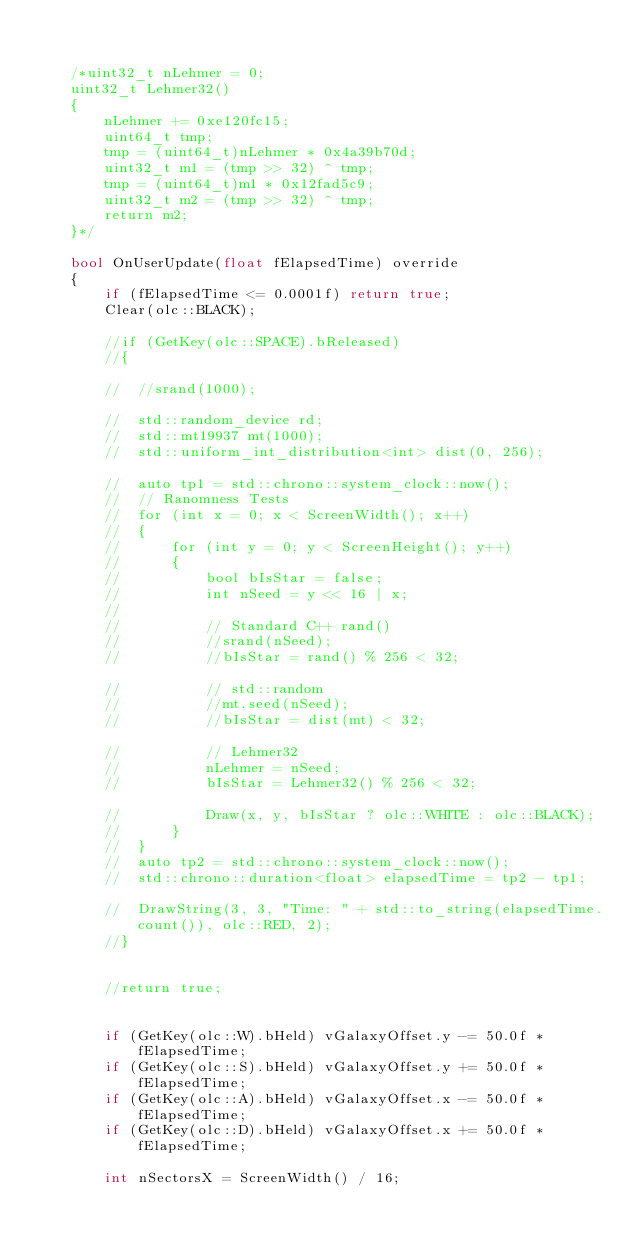<code> <loc_0><loc_0><loc_500><loc_500><_C++_>

	/*uint32_t nLehmer = 0;
	uint32_t Lehmer32()
	{
		nLehmer += 0xe120fc15;
		uint64_t tmp;
		tmp = (uint64_t)nLehmer * 0x4a39b70d;
		uint32_t m1 = (tmp >> 32) ^ tmp;
		tmp = (uint64_t)m1 * 0x12fad5c9;
		uint32_t m2 = (tmp >> 32) ^ tmp;
		return m2;
	}*/

	bool OnUserUpdate(float fElapsedTime) override
	{
		if (fElapsedTime <= 0.0001f) return true;
		Clear(olc::BLACK);

		//if (GetKey(olc::SPACE).bReleased)
		//{

		//	//srand(1000);

		//	std::random_device rd;
		//	std::mt19937 mt(1000);
		//	std::uniform_int_distribution<int> dist(0, 256);

		//	auto tp1 = std::chrono::system_clock::now();
		//	// Ranomness Tests
		//	for (int x = 0; x < ScreenWidth(); x++)
		//	{
		//		for (int y = 0; y < ScreenHeight(); y++)
		//		{
		//			bool bIsStar = false;
		//			int nSeed = y << 16 | x;
		//			
		//			// Standard C++ rand()
		//			//srand(nSeed);
		//			//bIsStar = rand() % 256 < 32;

		//			// std::random
		//			//mt.seed(nSeed);
		//			//bIsStar = dist(mt) < 32;

		//			// Lehmer32
		//			nLehmer = nSeed;
		//			bIsStar = Lehmer32() % 256 < 32;

		//			Draw(x, y, bIsStar ? olc::WHITE : olc::BLACK);
		//		}
		//	}
		//	auto tp2 = std::chrono::system_clock::now();
		//	std::chrono::duration<float> elapsedTime = tp2 - tp1;			
		//	DrawString(3, 3, "Time: " + std::to_string(elapsedTime.count()), olc::RED, 2);
		//}


		//return true;


		if (GetKey(olc::W).bHeld) vGalaxyOffset.y -= 50.0f * fElapsedTime;
		if (GetKey(olc::S).bHeld) vGalaxyOffset.y += 50.0f * fElapsedTime;
		if (GetKey(olc::A).bHeld) vGalaxyOffset.x -= 50.0f * fElapsedTime;
		if (GetKey(olc::D).bHeld) vGalaxyOffset.x += 50.0f * fElapsedTime;

		int nSectorsX = ScreenWidth() / 16;</code> 